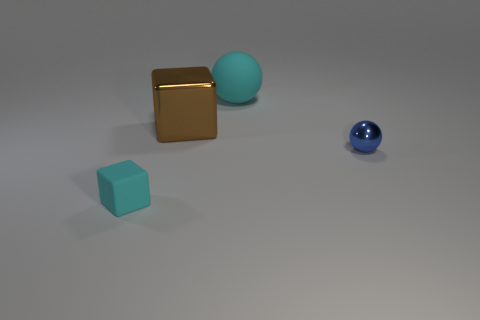Add 4 rubber objects. How many objects exist? 8 Subtract all big gray matte cylinders. Subtract all tiny cyan rubber objects. How many objects are left? 3 Add 2 metallic things. How many metallic things are left? 4 Add 3 tiny gray rubber blocks. How many tiny gray rubber blocks exist? 3 Subtract 1 brown cubes. How many objects are left? 3 Subtract all cyan balls. Subtract all green blocks. How many balls are left? 1 